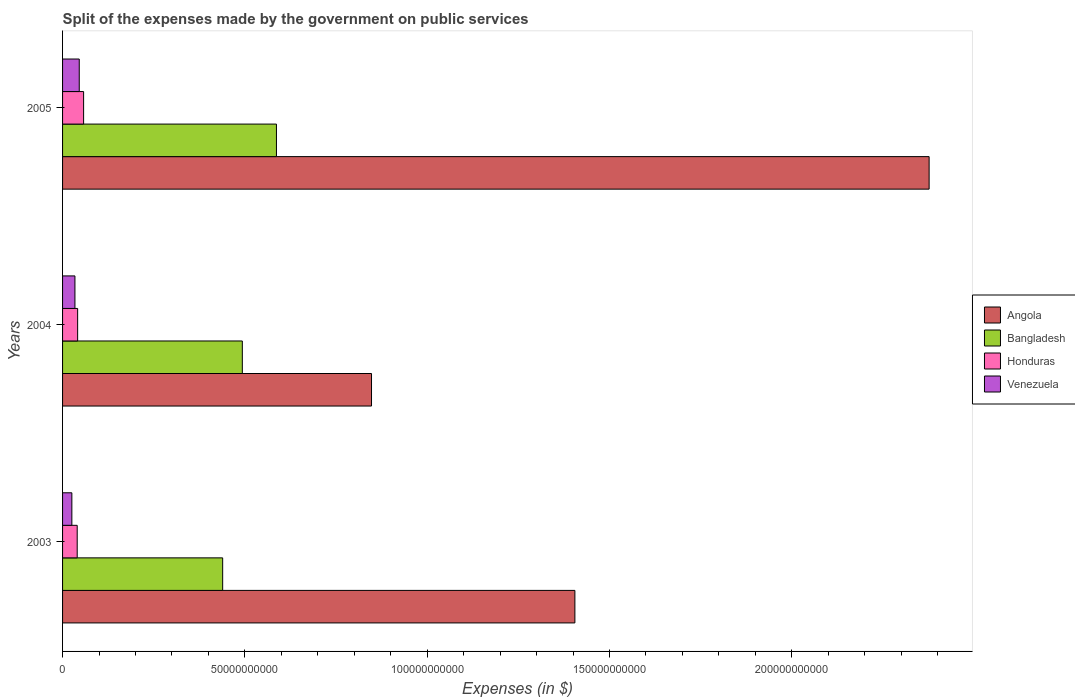How many different coloured bars are there?
Offer a terse response. 4. Are the number of bars on each tick of the Y-axis equal?
Make the answer very short. Yes. How many bars are there on the 1st tick from the top?
Ensure brevity in your answer.  4. How many bars are there on the 2nd tick from the bottom?
Offer a very short reply. 4. In how many cases, is the number of bars for a given year not equal to the number of legend labels?
Provide a short and direct response. 0. What is the expenses made by the government on public services in Bangladesh in 2004?
Offer a terse response. 4.93e+1. Across all years, what is the maximum expenses made by the government on public services in Venezuela?
Offer a very short reply. 4.57e+09. Across all years, what is the minimum expenses made by the government on public services in Angola?
Make the answer very short. 8.47e+1. In which year was the expenses made by the government on public services in Honduras minimum?
Give a very brief answer. 2003. What is the total expenses made by the government on public services in Venezuela in the graph?
Ensure brevity in your answer.  1.05e+1. What is the difference between the expenses made by the government on public services in Venezuela in 2004 and that in 2005?
Provide a short and direct response. -1.18e+09. What is the difference between the expenses made by the government on public services in Honduras in 2005 and the expenses made by the government on public services in Angola in 2003?
Give a very brief answer. -1.35e+11. What is the average expenses made by the government on public services in Angola per year?
Offer a very short reply. 1.54e+11. In the year 2003, what is the difference between the expenses made by the government on public services in Venezuela and expenses made by the government on public services in Bangladesh?
Provide a short and direct response. -4.14e+1. What is the ratio of the expenses made by the government on public services in Honduras in 2004 to that in 2005?
Offer a very short reply. 0.72. What is the difference between the highest and the second highest expenses made by the government on public services in Angola?
Ensure brevity in your answer.  9.71e+1. What is the difference between the highest and the lowest expenses made by the government on public services in Honduras?
Make the answer very short. 1.76e+09. In how many years, is the expenses made by the government on public services in Angola greater than the average expenses made by the government on public services in Angola taken over all years?
Your response must be concise. 1. What does the 3rd bar from the top in 2004 represents?
Give a very brief answer. Bangladesh. What does the 3rd bar from the bottom in 2003 represents?
Your answer should be very brief. Honduras. Is it the case that in every year, the sum of the expenses made by the government on public services in Angola and expenses made by the government on public services in Honduras is greater than the expenses made by the government on public services in Venezuela?
Your answer should be very brief. Yes. Are all the bars in the graph horizontal?
Make the answer very short. Yes. Are the values on the major ticks of X-axis written in scientific E-notation?
Your answer should be compact. No. How are the legend labels stacked?
Keep it short and to the point. Vertical. What is the title of the graph?
Offer a very short reply. Split of the expenses made by the government on public services. What is the label or title of the X-axis?
Provide a short and direct response. Expenses (in $). What is the label or title of the Y-axis?
Offer a very short reply. Years. What is the Expenses (in $) of Angola in 2003?
Offer a terse response. 1.40e+11. What is the Expenses (in $) of Bangladesh in 2003?
Your answer should be compact. 4.39e+1. What is the Expenses (in $) in Honduras in 2003?
Offer a terse response. 4.01e+09. What is the Expenses (in $) in Venezuela in 2003?
Provide a succinct answer. 2.55e+09. What is the Expenses (in $) in Angola in 2004?
Ensure brevity in your answer.  8.47e+1. What is the Expenses (in $) of Bangladesh in 2004?
Offer a very short reply. 4.93e+1. What is the Expenses (in $) in Honduras in 2004?
Keep it short and to the point. 4.13e+09. What is the Expenses (in $) in Venezuela in 2004?
Provide a short and direct response. 3.39e+09. What is the Expenses (in $) in Angola in 2005?
Provide a succinct answer. 2.38e+11. What is the Expenses (in $) in Bangladesh in 2005?
Give a very brief answer. 5.87e+1. What is the Expenses (in $) of Honduras in 2005?
Your response must be concise. 5.77e+09. What is the Expenses (in $) of Venezuela in 2005?
Offer a terse response. 4.57e+09. Across all years, what is the maximum Expenses (in $) of Angola?
Make the answer very short. 2.38e+11. Across all years, what is the maximum Expenses (in $) of Bangladesh?
Provide a short and direct response. 5.87e+1. Across all years, what is the maximum Expenses (in $) in Honduras?
Your answer should be very brief. 5.77e+09. Across all years, what is the maximum Expenses (in $) of Venezuela?
Make the answer very short. 4.57e+09. Across all years, what is the minimum Expenses (in $) in Angola?
Offer a terse response. 8.47e+1. Across all years, what is the minimum Expenses (in $) in Bangladesh?
Provide a short and direct response. 4.39e+1. Across all years, what is the minimum Expenses (in $) in Honduras?
Your answer should be compact. 4.01e+09. Across all years, what is the minimum Expenses (in $) of Venezuela?
Make the answer very short. 2.55e+09. What is the total Expenses (in $) in Angola in the graph?
Provide a short and direct response. 4.63e+11. What is the total Expenses (in $) in Bangladesh in the graph?
Provide a succinct answer. 1.52e+11. What is the total Expenses (in $) of Honduras in the graph?
Provide a succinct answer. 1.39e+1. What is the total Expenses (in $) of Venezuela in the graph?
Your answer should be compact. 1.05e+1. What is the difference between the Expenses (in $) of Angola in 2003 and that in 2004?
Make the answer very short. 5.58e+1. What is the difference between the Expenses (in $) of Bangladesh in 2003 and that in 2004?
Your response must be concise. -5.39e+09. What is the difference between the Expenses (in $) of Honduras in 2003 and that in 2004?
Offer a terse response. -1.20e+08. What is the difference between the Expenses (in $) in Venezuela in 2003 and that in 2004?
Your answer should be very brief. -8.44e+08. What is the difference between the Expenses (in $) of Angola in 2003 and that in 2005?
Ensure brevity in your answer.  -9.71e+1. What is the difference between the Expenses (in $) in Bangladesh in 2003 and that in 2005?
Provide a succinct answer. -1.48e+1. What is the difference between the Expenses (in $) in Honduras in 2003 and that in 2005?
Offer a terse response. -1.76e+09. What is the difference between the Expenses (in $) of Venezuela in 2003 and that in 2005?
Give a very brief answer. -2.02e+09. What is the difference between the Expenses (in $) of Angola in 2004 and that in 2005?
Keep it short and to the point. -1.53e+11. What is the difference between the Expenses (in $) in Bangladesh in 2004 and that in 2005?
Your answer should be compact. -9.36e+09. What is the difference between the Expenses (in $) in Honduras in 2004 and that in 2005?
Keep it short and to the point. -1.64e+09. What is the difference between the Expenses (in $) of Venezuela in 2004 and that in 2005?
Provide a short and direct response. -1.18e+09. What is the difference between the Expenses (in $) of Angola in 2003 and the Expenses (in $) of Bangladesh in 2004?
Give a very brief answer. 9.12e+1. What is the difference between the Expenses (in $) of Angola in 2003 and the Expenses (in $) of Honduras in 2004?
Ensure brevity in your answer.  1.36e+11. What is the difference between the Expenses (in $) in Angola in 2003 and the Expenses (in $) in Venezuela in 2004?
Make the answer very short. 1.37e+11. What is the difference between the Expenses (in $) in Bangladesh in 2003 and the Expenses (in $) in Honduras in 2004?
Provide a succinct answer. 3.98e+1. What is the difference between the Expenses (in $) of Bangladesh in 2003 and the Expenses (in $) of Venezuela in 2004?
Your answer should be very brief. 4.05e+1. What is the difference between the Expenses (in $) of Honduras in 2003 and the Expenses (in $) of Venezuela in 2004?
Ensure brevity in your answer.  6.18e+08. What is the difference between the Expenses (in $) in Angola in 2003 and the Expenses (in $) in Bangladesh in 2005?
Provide a succinct answer. 8.18e+1. What is the difference between the Expenses (in $) in Angola in 2003 and the Expenses (in $) in Honduras in 2005?
Keep it short and to the point. 1.35e+11. What is the difference between the Expenses (in $) in Angola in 2003 and the Expenses (in $) in Venezuela in 2005?
Provide a succinct answer. 1.36e+11. What is the difference between the Expenses (in $) in Bangladesh in 2003 and the Expenses (in $) in Honduras in 2005?
Give a very brief answer. 3.81e+1. What is the difference between the Expenses (in $) of Bangladesh in 2003 and the Expenses (in $) of Venezuela in 2005?
Your answer should be very brief. 3.93e+1. What is the difference between the Expenses (in $) of Honduras in 2003 and the Expenses (in $) of Venezuela in 2005?
Ensure brevity in your answer.  -5.62e+08. What is the difference between the Expenses (in $) in Angola in 2004 and the Expenses (in $) in Bangladesh in 2005?
Ensure brevity in your answer.  2.61e+1. What is the difference between the Expenses (in $) in Angola in 2004 and the Expenses (in $) in Honduras in 2005?
Offer a terse response. 7.90e+1. What is the difference between the Expenses (in $) in Angola in 2004 and the Expenses (in $) in Venezuela in 2005?
Your response must be concise. 8.02e+1. What is the difference between the Expenses (in $) in Bangladesh in 2004 and the Expenses (in $) in Honduras in 2005?
Keep it short and to the point. 4.35e+1. What is the difference between the Expenses (in $) in Bangladesh in 2004 and the Expenses (in $) in Venezuela in 2005?
Your answer should be compact. 4.47e+1. What is the difference between the Expenses (in $) of Honduras in 2004 and the Expenses (in $) of Venezuela in 2005?
Provide a succinct answer. -4.42e+08. What is the average Expenses (in $) in Angola per year?
Offer a terse response. 1.54e+11. What is the average Expenses (in $) of Bangladesh per year?
Offer a very short reply. 5.06e+1. What is the average Expenses (in $) of Honduras per year?
Give a very brief answer. 4.64e+09. What is the average Expenses (in $) in Venezuela per year?
Offer a very short reply. 3.51e+09. In the year 2003, what is the difference between the Expenses (in $) of Angola and Expenses (in $) of Bangladesh?
Provide a succinct answer. 9.66e+1. In the year 2003, what is the difference between the Expenses (in $) of Angola and Expenses (in $) of Honduras?
Ensure brevity in your answer.  1.36e+11. In the year 2003, what is the difference between the Expenses (in $) of Angola and Expenses (in $) of Venezuela?
Your answer should be very brief. 1.38e+11. In the year 2003, what is the difference between the Expenses (in $) of Bangladesh and Expenses (in $) of Honduras?
Your answer should be compact. 3.99e+1. In the year 2003, what is the difference between the Expenses (in $) in Bangladesh and Expenses (in $) in Venezuela?
Your response must be concise. 4.14e+1. In the year 2003, what is the difference between the Expenses (in $) in Honduras and Expenses (in $) in Venezuela?
Offer a terse response. 1.46e+09. In the year 2004, what is the difference between the Expenses (in $) of Angola and Expenses (in $) of Bangladesh?
Make the answer very short. 3.54e+1. In the year 2004, what is the difference between the Expenses (in $) of Angola and Expenses (in $) of Honduras?
Make the answer very short. 8.06e+1. In the year 2004, what is the difference between the Expenses (in $) in Angola and Expenses (in $) in Venezuela?
Your answer should be compact. 8.13e+1. In the year 2004, what is the difference between the Expenses (in $) in Bangladesh and Expenses (in $) in Honduras?
Your response must be concise. 4.52e+1. In the year 2004, what is the difference between the Expenses (in $) in Bangladesh and Expenses (in $) in Venezuela?
Give a very brief answer. 4.59e+1. In the year 2004, what is the difference between the Expenses (in $) of Honduras and Expenses (in $) of Venezuela?
Provide a short and direct response. 7.38e+08. In the year 2005, what is the difference between the Expenses (in $) in Angola and Expenses (in $) in Bangladesh?
Keep it short and to the point. 1.79e+11. In the year 2005, what is the difference between the Expenses (in $) in Angola and Expenses (in $) in Honduras?
Your response must be concise. 2.32e+11. In the year 2005, what is the difference between the Expenses (in $) in Angola and Expenses (in $) in Venezuela?
Your response must be concise. 2.33e+11. In the year 2005, what is the difference between the Expenses (in $) of Bangladesh and Expenses (in $) of Honduras?
Offer a very short reply. 5.29e+1. In the year 2005, what is the difference between the Expenses (in $) of Bangladesh and Expenses (in $) of Venezuela?
Give a very brief answer. 5.41e+1. In the year 2005, what is the difference between the Expenses (in $) in Honduras and Expenses (in $) in Venezuela?
Offer a very short reply. 1.20e+09. What is the ratio of the Expenses (in $) in Angola in 2003 to that in 2004?
Offer a terse response. 1.66. What is the ratio of the Expenses (in $) in Bangladesh in 2003 to that in 2004?
Give a very brief answer. 0.89. What is the ratio of the Expenses (in $) of Honduras in 2003 to that in 2004?
Make the answer very short. 0.97. What is the ratio of the Expenses (in $) of Venezuela in 2003 to that in 2004?
Offer a very short reply. 0.75. What is the ratio of the Expenses (in $) in Angola in 2003 to that in 2005?
Provide a short and direct response. 0.59. What is the ratio of the Expenses (in $) in Bangladesh in 2003 to that in 2005?
Your response must be concise. 0.75. What is the ratio of the Expenses (in $) of Honduras in 2003 to that in 2005?
Offer a terse response. 0.7. What is the ratio of the Expenses (in $) of Venezuela in 2003 to that in 2005?
Ensure brevity in your answer.  0.56. What is the ratio of the Expenses (in $) of Angola in 2004 to that in 2005?
Your answer should be compact. 0.36. What is the ratio of the Expenses (in $) of Bangladesh in 2004 to that in 2005?
Make the answer very short. 0.84. What is the ratio of the Expenses (in $) in Honduras in 2004 to that in 2005?
Give a very brief answer. 0.72. What is the ratio of the Expenses (in $) of Venezuela in 2004 to that in 2005?
Your answer should be compact. 0.74. What is the difference between the highest and the second highest Expenses (in $) in Angola?
Provide a succinct answer. 9.71e+1. What is the difference between the highest and the second highest Expenses (in $) in Bangladesh?
Keep it short and to the point. 9.36e+09. What is the difference between the highest and the second highest Expenses (in $) of Honduras?
Provide a short and direct response. 1.64e+09. What is the difference between the highest and the second highest Expenses (in $) of Venezuela?
Offer a terse response. 1.18e+09. What is the difference between the highest and the lowest Expenses (in $) in Angola?
Provide a short and direct response. 1.53e+11. What is the difference between the highest and the lowest Expenses (in $) in Bangladesh?
Ensure brevity in your answer.  1.48e+1. What is the difference between the highest and the lowest Expenses (in $) in Honduras?
Keep it short and to the point. 1.76e+09. What is the difference between the highest and the lowest Expenses (in $) in Venezuela?
Provide a short and direct response. 2.02e+09. 